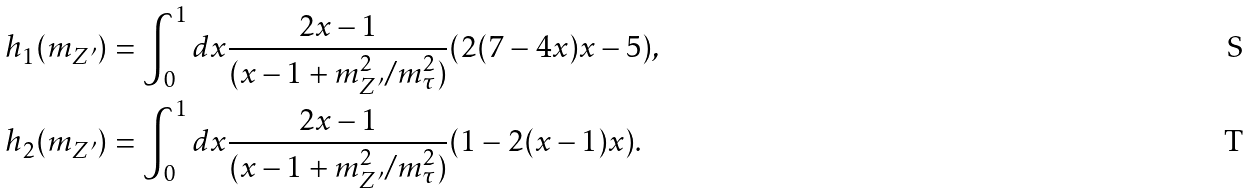<formula> <loc_0><loc_0><loc_500><loc_500>h _ { 1 } ( m _ { Z ^ { \prime } } ) & = \int _ { 0 } ^ { 1 } d x \frac { 2 x - 1 } { ( x - 1 + m ^ { 2 } _ { Z ^ { \prime } } / m _ { \tau } ^ { 2 } ) } ( 2 ( 7 - 4 x ) x - 5 ) , \\ h _ { 2 } ( m _ { Z ^ { \prime } } ) & = \int _ { 0 } ^ { 1 } d x \frac { 2 x - 1 } { ( x - 1 + m ^ { 2 } _ { Z ^ { \prime } } / m _ { \tau } ^ { 2 } ) } ( 1 - 2 ( x - 1 ) x ) .</formula> 